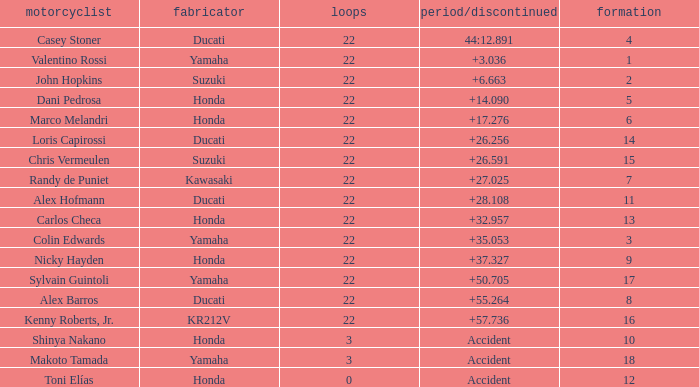What is the average grid for competitors who had more than 22 laps and time/retired of +17.276? None. 